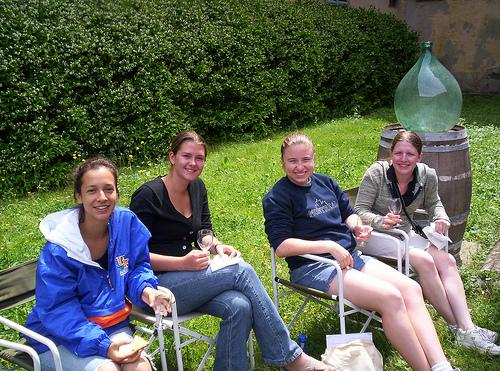Question: where are they?
Choices:
A. Playing.
B. Standing.
C. Running.
D. Sitting.
Answer with the letter. Answer: D Question: what is the girl wearing?
Choices:
A. Jacket.
B. Jeans.
C. Dress.
D. Skirt.
Answer with the letter. Answer: A 